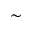Convert formula to latex. <formula><loc_0><loc_0><loc_500><loc_500>\sim</formula> 